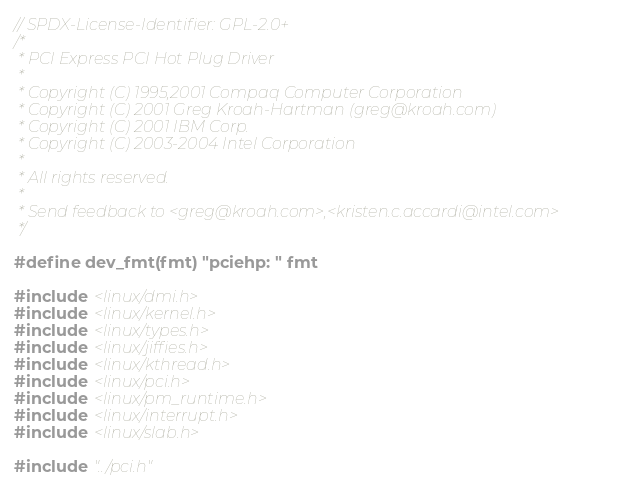<code> <loc_0><loc_0><loc_500><loc_500><_C_>// SPDX-License-Identifier: GPL-2.0+
/*
 * PCI Express PCI Hot Plug Driver
 *
 * Copyright (C) 1995,2001 Compaq Computer Corporation
 * Copyright (C) 2001 Greg Kroah-Hartman (greg@kroah.com)
 * Copyright (C) 2001 IBM Corp.
 * Copyright (C) 2003-2004 Intel Corporation
 *
 * All rights reserved.
 *
 * Send feedback to <greg@kroah.com>,<kristen.c.accardi@intel.com>
 */

#define dev_fmt(fmt) "pciehp: " fmt

#include <linux/dmi.h>
#include <linux/kernel.h>
#include <linux/types.h>
#include <linux/jiffies.h>
#include <linux/kthread.h>
#include <linux/pci.h>
#include <linux/pm_runtime.h>
#include <linux/interrupt.h>
#include <linux/slab.h>

#include "../pci.h"</code> 